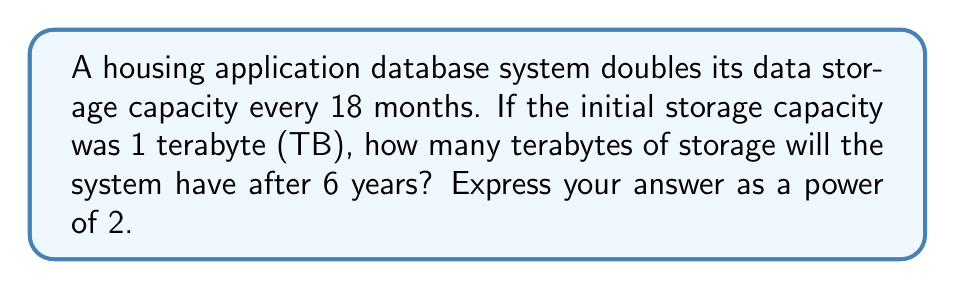Help me with this question. Let's approach this step-by-step:

1. First, we need to determine how many 18-month periods are in 6 years:
   $$ \frac{6 \text{ years}}{1.5 \text{ years}} = 4 \text{ periods} $$

2. The growth pattern follows an exponential function:
   $$ C(t) = C_0 \cdot 2^t $$
   Where $C_0$ is the initial capacity, and $t$ is the number of periods.

3. We know that $C_0 = 1$ TB and $t = 4$, so we can plug these into our equation:
   $$ C(4) = 1 \cdot 2^4 $$

4. Simplify:
   $$ C(4) = 2^4 = 16 \text{ TB} $$

This result shows how quickly data storage can grow, potentially leading to vast amounts of personal information being collected and stored over time, which could be used in algorithmic decision-making processes.
Answer: $2^4$ TB or 16 TB 